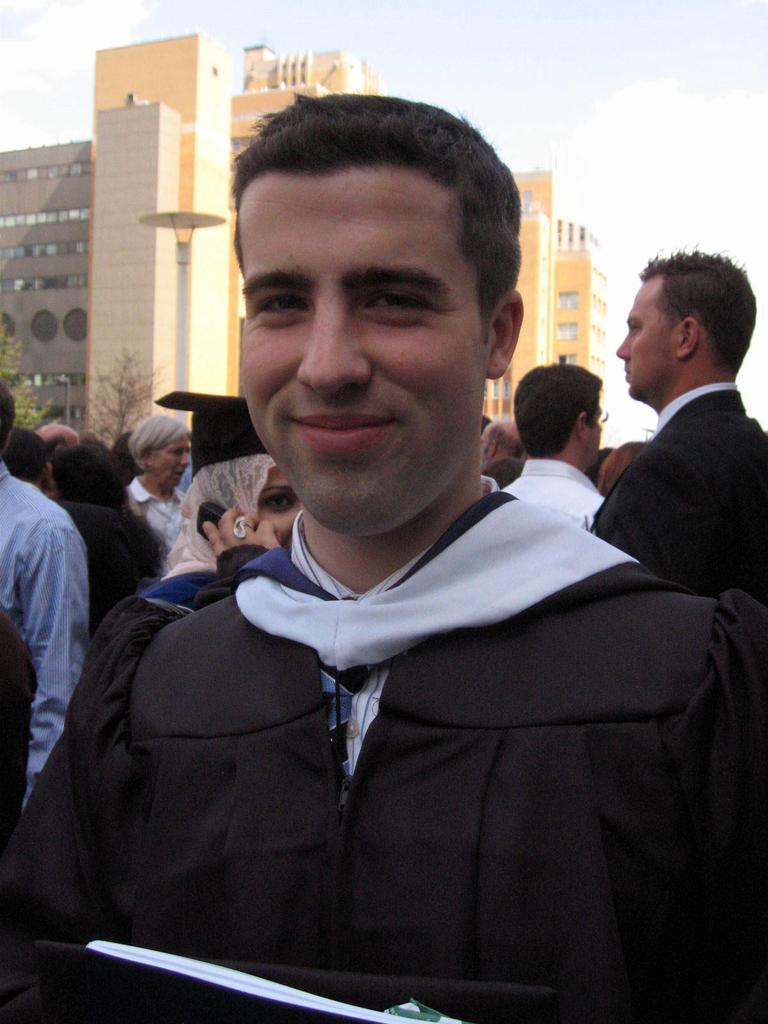In one or two sentences, can you explain what this image depicts? In this image we can see a man. He is wearing a black color dress. In the background, we can see people and buildings. At the top of the image, we can see the sky with some clouds. There is an object at the bottom of the image. 